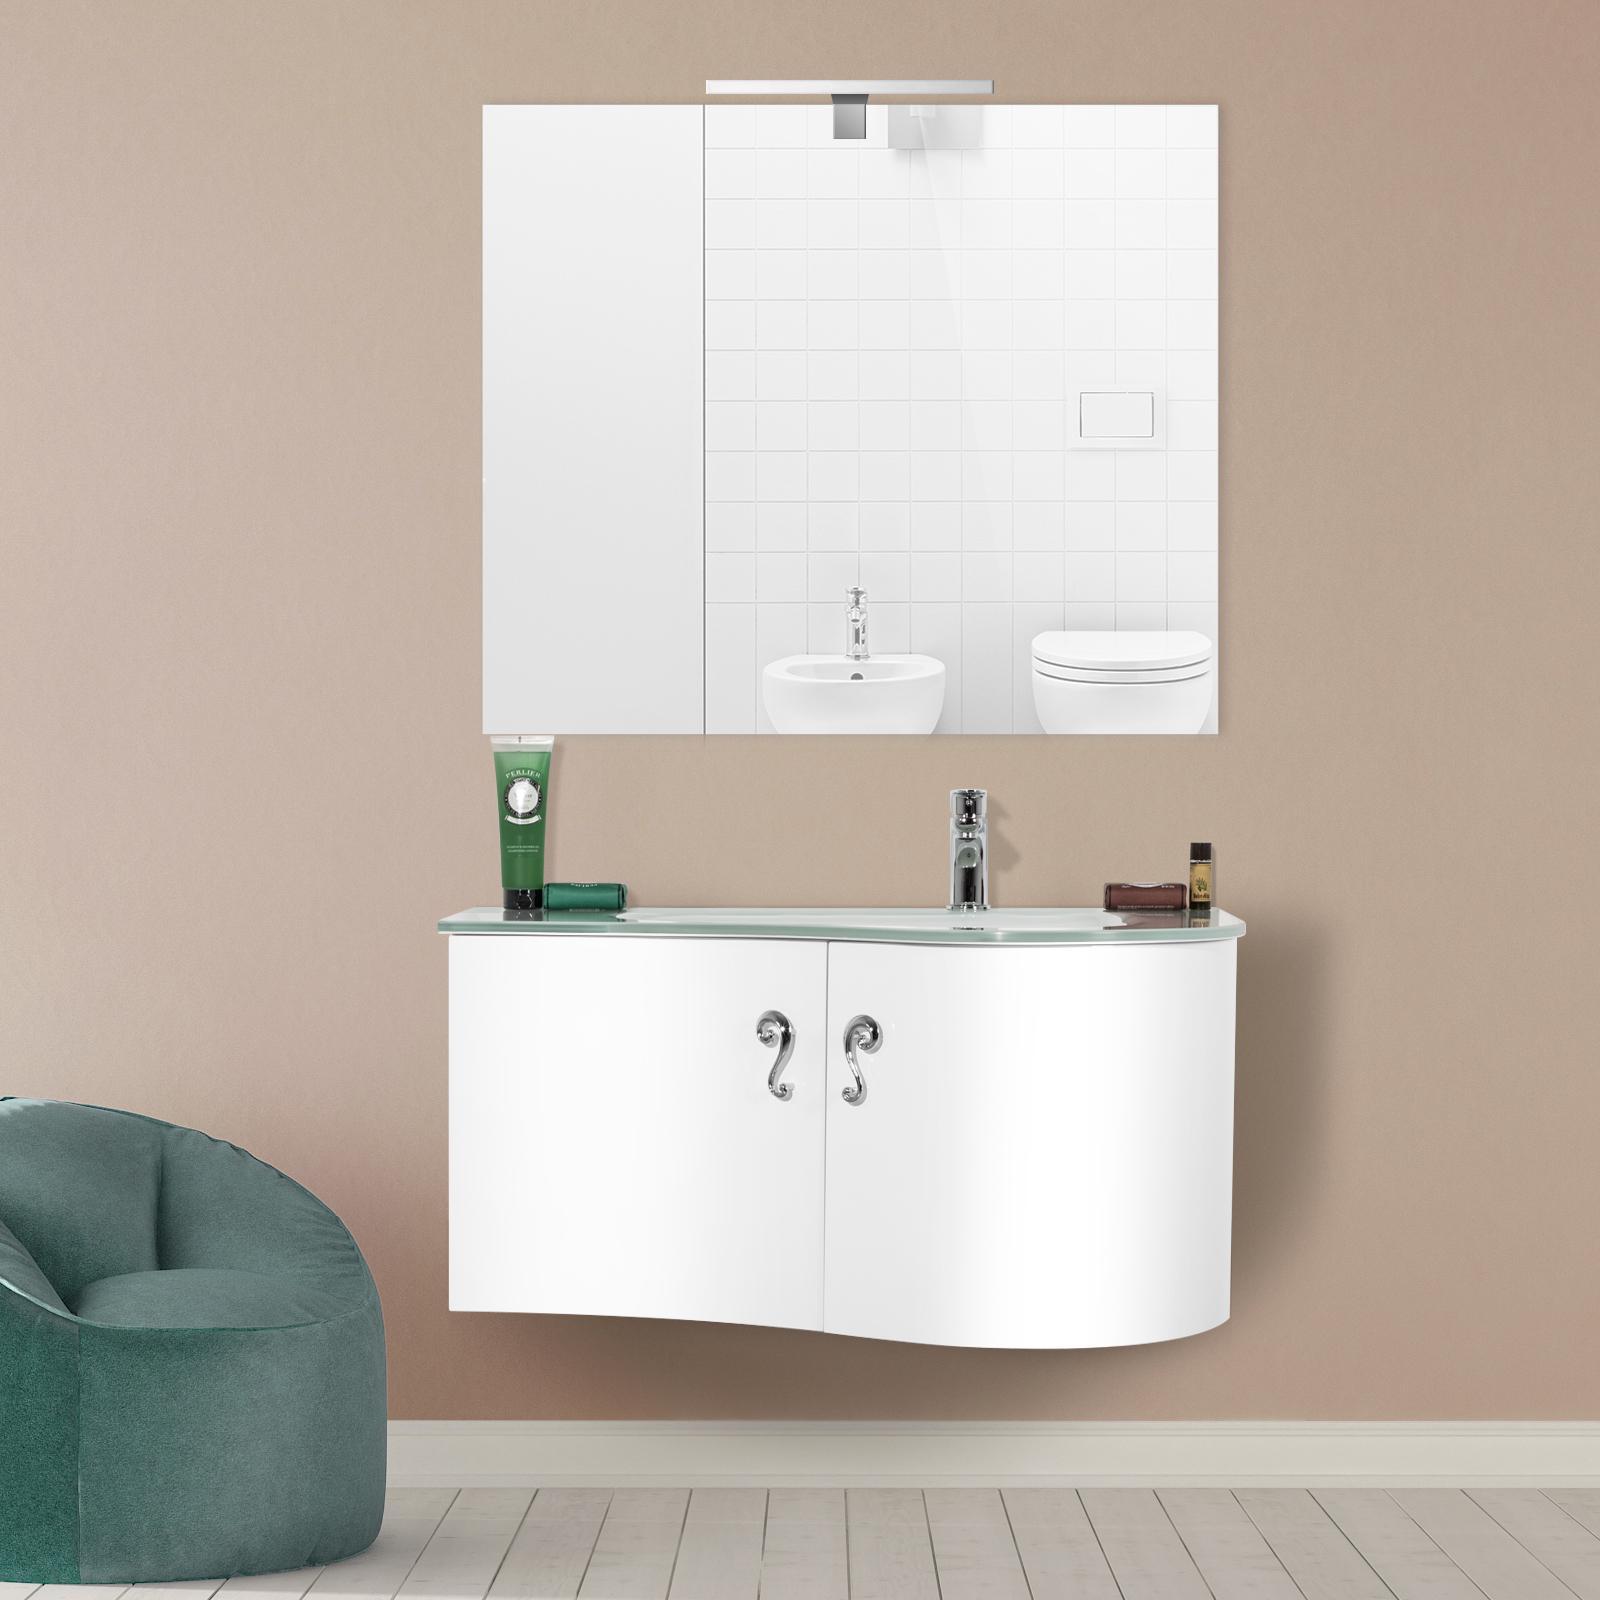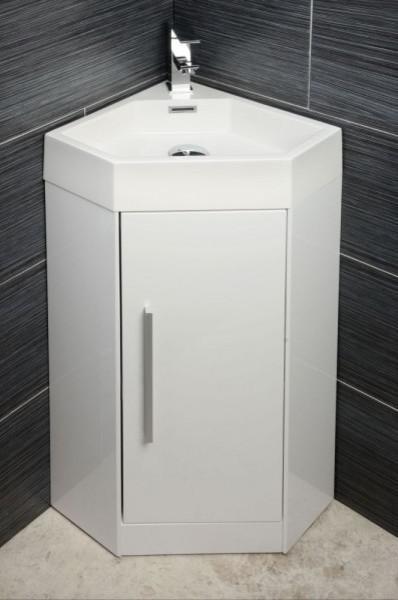The first image is the image on the left, the second image is the image on the right. Analyze the images presented: Is the assertion "IN at least one image there is a single raised basin on top of a floating cabinet shelf." valid? Answer yes or no. No. The first image is the image on the left, the second image is the image on the right. Given the left and right images, does the statement "One of the sinks is a bowl type." hold true? Answer yes or no. No. 